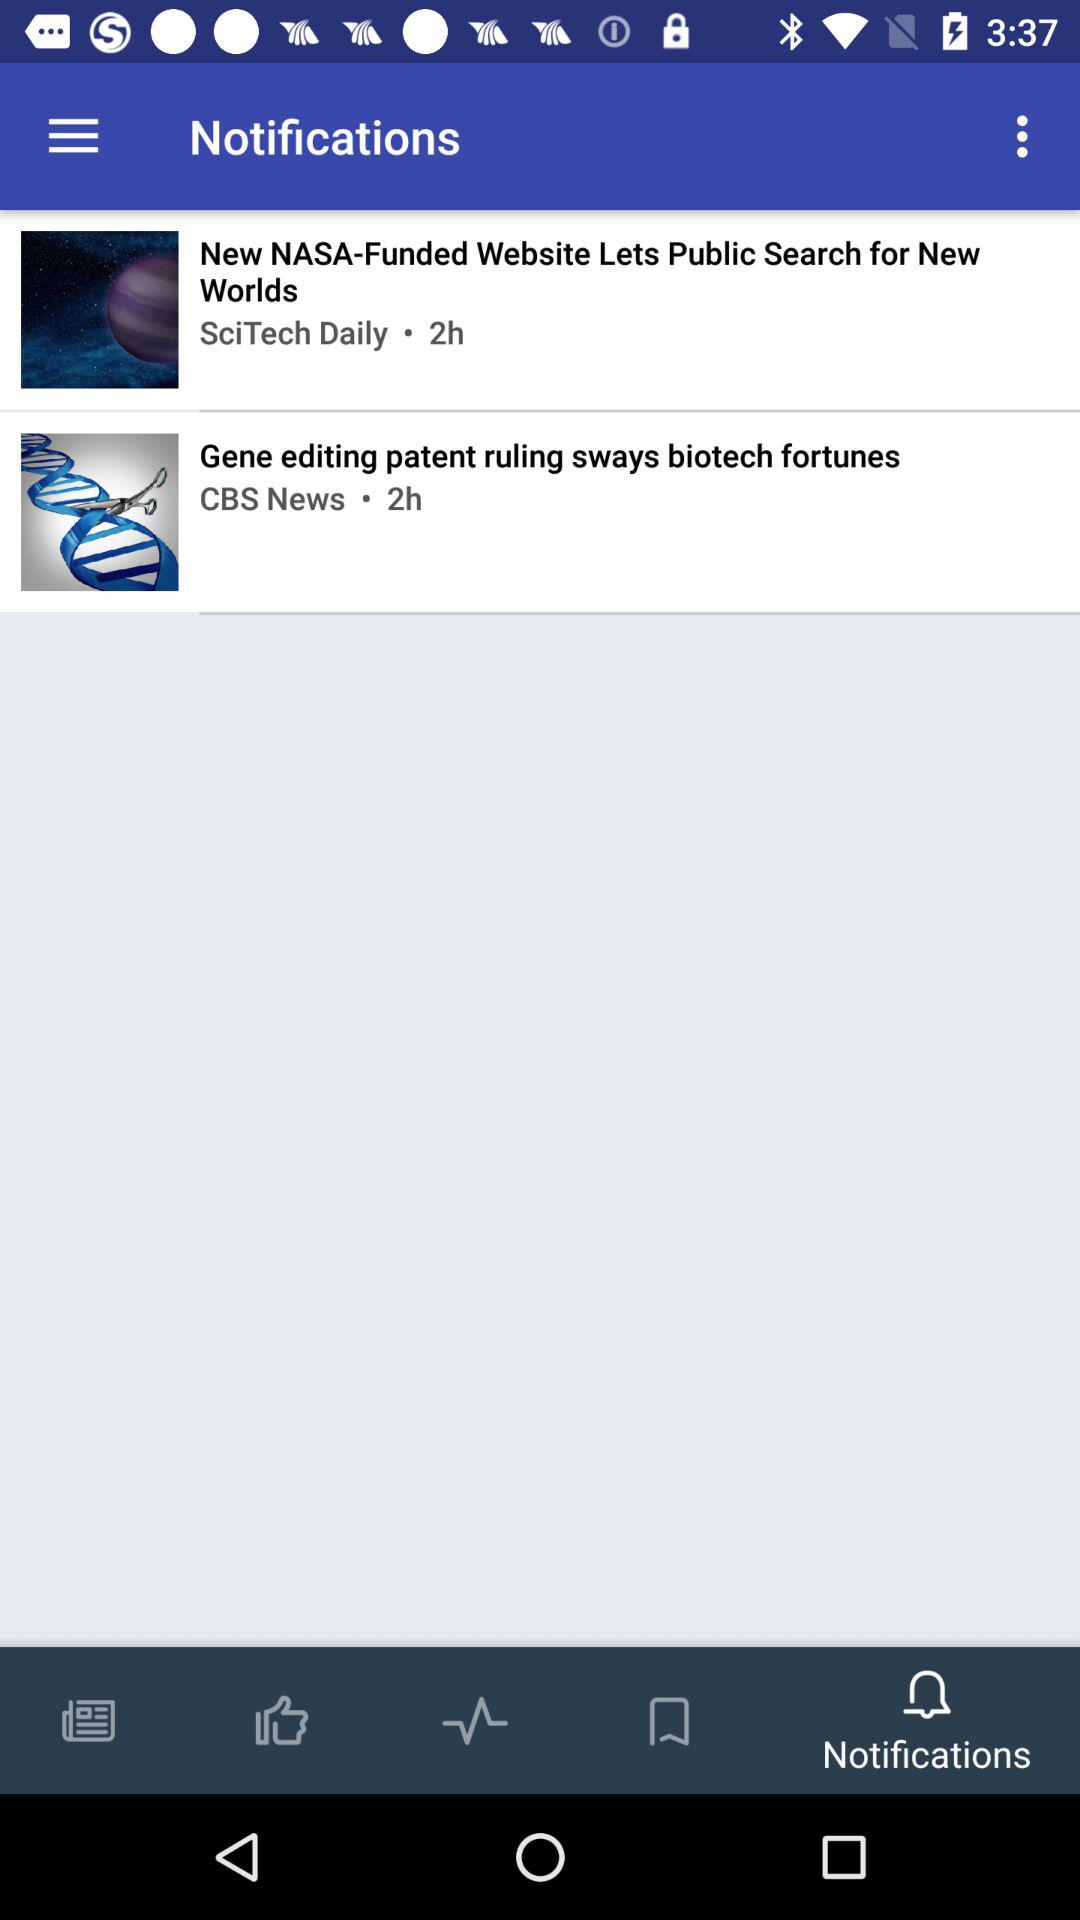What are the news channel names? The news channel names are "SciTech Daily" and "CBS News". 